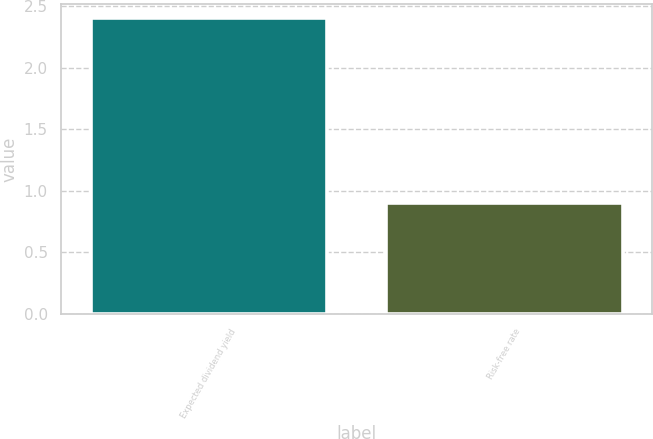Convert chart. <chart><loc_0><loc_0><loc_500><loc_500><bar_chart><fcel>Expected dividend yield<fcel>Risk-free rate<nl><fcel>2.4<fcel>0.9<nl></chart> 